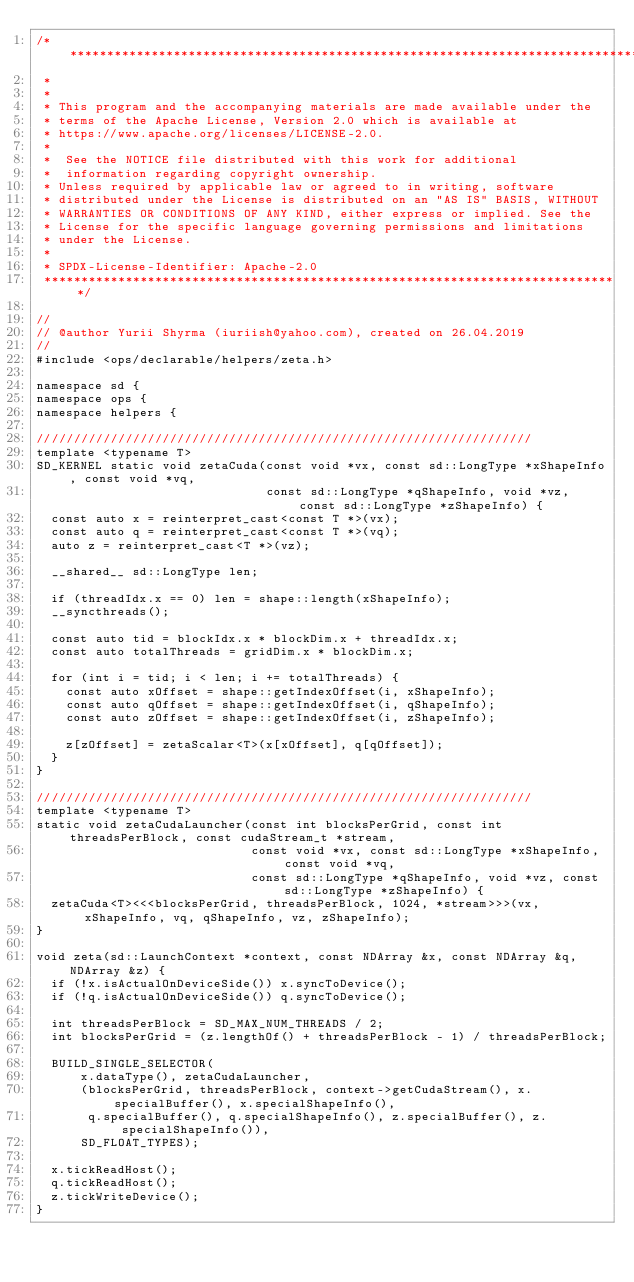<code> <loc_0><loc_0><loc_500><loc_500><_Cuda_>/* ******************************************************************************
 *
 *
 * This program and the accompanying materials are made available under the
 * terms of the Apache License, Version 2.0 which is available at
 * https://www.apache.org/licenses/LICENSE-2.0.
 *
 *  See the NOTICE file distributed with this work for additional
 *  information regarding copyright ownership.
 * Unless required by applicable law or agreed to in writing, software
 * distributed under the License is distributed on an "AS IS" BASIS, WITHOUT
 * WARRANTIES OR CONDITIONS OF ANY KIND, either express or implied. See the
 * License for the specific language governing permissions and limitations
 * under the License.
 *
 * SPDX-License-Identifier: Apache-2.0
 ******************************************************************************/

//
// @author Yurii Shyrma (iuriish@yahoo.com), created on 26.04.2019
//
#include <ops/declarable/helpers/zeta.h>

namespace sd {
namespace ops {
namespace helpers {

///////////////////////////////////////////////////////////////////
template <typename T>
SD_KERNEL static void zetaCuda(const void *vx, const sd::LongType *xShapeInfo, const void *vq,
                               const sd::LongType *qShapeInfo, void *vz, const sd::LongType *zShapeInfo) {
  const auto x = reinterpret_cast<const T *>(vx);
  const auto q = reinterpret_cast<const T *>(vq);
  auto z = reinterpret_cast<T *>(vz);

  __shared__ sd::LongType len;

  if (threadIdx.x == 0) len = shape::length(xShapeInfo);
  __syncthreads();

  const auto tid = blockIdx.x * blockDim.x + threadIdx.x;
  const auto totalThreads = gridDim.x * blockDim.x;

  for (int i = tid; i < len; i += totalThreads) {
    const auto xOffset = shape::getIndexOffset(i, xShapeInfo);
    const auto qOffset = shape::getIndexOffset(i, qShapeInfo);
    const auto zOffset = shape::getIndexOffset(i, zShapeInfo);

    z[zOffset] = zetaScalar<T>(x[xOffset], q[qOffset]);
  }
}

///////////////////////////////////////////////////////////////////
template <typename T>
static void zetaCudaLauncher(const int blocksPerGrid, const int threadsPerBlock, const cudaStream_t *stream,
                             const void *vx, const sd::LongType *xShapeInfo, const void *vq,
                             const sd::LongType *qShapeInfo, void *vz, const sd::LongType *zShapeInfo) {
  zetaCuda<T><<<blocksPerGrid, threadsPerBlock, 1024, *stream>>>(vx, xShapeInfo, vq, qShapeInfo, vz, zShapeInfo);
}

void zeta(sd::LaunchContext *context, const NDArray &x, const NDArray &q, NDArray &z) {
  if (!x.isActualOnDeviceSide()) x.syncToDevice();
  if (!q.isActualOnDeviceSide()) q.syncToDevice();

  int threadsPerBlock = SD_MAX_NUM_THREADS / 2;
  int blocksPerGrid = (z.lengthOf() + threadsPerBlock - 1) / threadsPerBlock;

  BUILD_SINGLE_SELECTOR(
      x.dataType(), zetaCudaLauncher,
      (blocksPerGrid, threadsPerBlock, context->getCudaStream(), x.specialBuffer(), x.specialShapeInfo(),
       q.specialBuffer(), q.specialShapeInfo(), z.specialBuffer(), z.specialShapeInfo()),
      SD_FLOAT_TYPES);

  x.tickReadHost();
  q.tickReadHost();
  z.tickWriteDevice();
}
</code> 